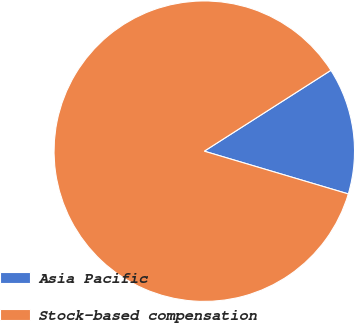<chart> <loc_0><loc_0><loc_500><loc_500><pie_chart><fcel>Asia Pacific<fcel>Stock-based compensation<nl><fcel>13.64%<fcel>86.36%<nl></chart> 